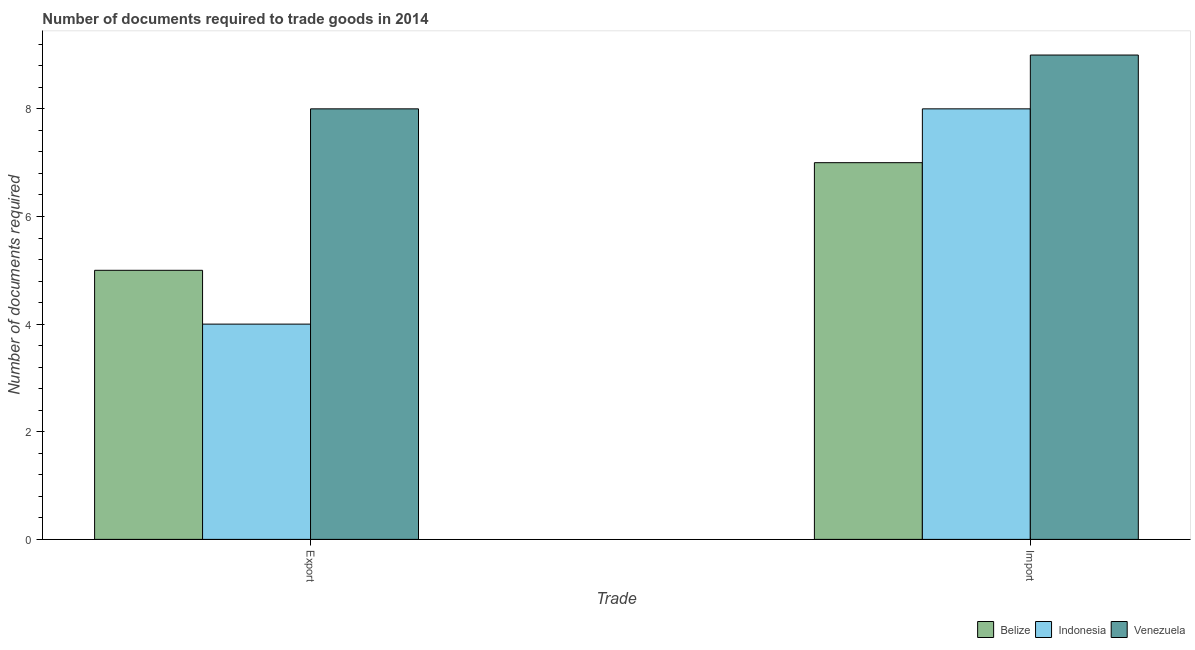How many groups of bars are there?
Offer a very short reply. 2. How many bars are there on the 1st tick from the right?
Make the answer very short. 3. What is the label of the 2nd group of bars from the left?
Your response must be concise. Import. What is the number of documents required to export goods in Belize?
Offer a terse response. 5. Across all countries, what is the maximum number of documents required to export goods?
Ensure brevity in your answer.  8. Across all countries, what is the minimum number of documents required to import goods?
Ensure brevity in your answer.  7. In which country was the number of documents required to export goods maximum?
Provide a short and direct response. Venezuela. In which country was the number of documents required to import goods minimum?
Your answer should be very brief. Belize. What is the total number of documents required to import goods in the graph?
Provide a short and direct response. 24. What is the difference between the number of documents required to export goods in Venezuela and that in Belize?
Your answer should be very brief. 3. What is the difference between the number of documents required to import goods in Venezuela and the number of documents required to export goods in Belize?
Provide a short and direct response. 4. What is the average number of documents required to export goods per country?
Your answer should be very brief. 5.67. What is the difference between the number of documents required to import goods and number of documents required to export goods in Belize?
Your response must be concise. 2. In how many countries, is the number of documents required to import goods greater than 7.2 ?
Offer a very short reply. 2. In how many countries, is the number of documents required to import goods greater than the average number of documents required to import goods taken over all countries?
Your answer should be compact. 1. What does the 1st bar from the right in Export represents?
Give a very brief answer. Venezuela. How many bars are there?
Offer a terse response. 6. How many countries are there in the graph?
Keep it short and to the point. 3. Are the values on the major ticks of Y-axis written in scientific E-notation?
Offer a very short reply. No. Does the graph contain any zero values?
Your answer should be compact. No. Where does the legend appear in the graph?
Provide a succinct answer. Bottom right. What is the title of the graph?
Your response must be concise. Number of documents required to trade goods in 2014. What is the label or title of the X-axis?
Your response must be concise. Trade. What is the label or title of the Y-axis?
Make the answer very short. Number of documents required. What is the Number of documents required in Venezuela in Export?
Give a very brief answer. 8. What is the Number of documents required of Belize in Import?
Your answer should be compact. 7. What is the Number of documents required in Venezuela in Import?
Offer a terse response. 9. Across all Trade, what is the maximum Number of documents required in Indonesia?
Offer a very short reply. 8. Across all Trade, what is the maximum Number of documents required in Venezuela?
Your answer should be very brief. 9. Across all Trade, what is the minimum Number of documents required of Indonesia?
Your response must be concise. 4. What is the total Number of documents required of Belize in the graph?
Your answer should be compact. 12. What is the total Number of documents required in Indonesia in the graph?
Ensure brevity in your answer.  12. What is the total Number of documents required in Venezuela in the graph?
Offer a very short reply. 17. What is the difference between the Number of documents required in Belize in Export and that in Import?
Offer a terse response. -2. What is the difference between the Number of documents required in Belize in Export and the Number of documents required in Indonesia in Import?
Your answer should be very brief. -3. What is the difference between the Number of documents required in Indonesia in Export and the Number of documents required in Venezuela in Import?
Make the answer very short. -5. What is the average Number of documents required in Belize per Trade?
Make the answer very short. 6. What is the average Number of documents required in Venezuela per Trade?
Make the answer very short. 8.5. What is the difference between the Number of documents required of Belize and Number of documents required of Indonesia in Export?
Provide a succinct answer. 1. What is the difference between the Number of documents required in Belize and Number of documents required in Venezuela in Export?
Give a very brief answer. -3. What is the difference between the Number of documents required in Indonesia and Number of documents required in Venezuela in Export?
Make the answer very short. -4. What is the difference between the Number of documents required in Belize and Number of documents required in Indonesia in Import?
Provide a short and direct response. -1. What is the difference between the Number of documents required of Belize and Number of documents required of Venezuela in Import?
Give a very brief answer. -2. What is the difference between the Number of documents required in Indonesia and Number of documents required in Venezuela in Import?
Provide a succinct answer. -1. What is the ratio of the Number of documents required in Belize in Export to that in Import?
Your response must be concise. 0.71. What is the ratio of the Number of documents required in Venezuela in Export to that in Import?
Offer a very short reply. 0.89. What is the difference between the highest and the lowest Number of documents required in Belize?
Keep it short and to the point. 2. 